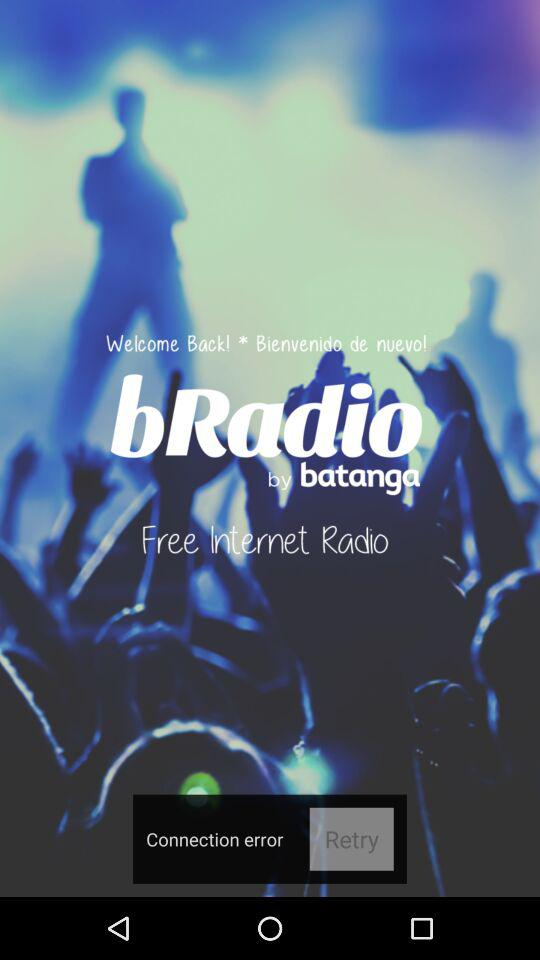What is the name of the application? The name of the application is "bRadio". 